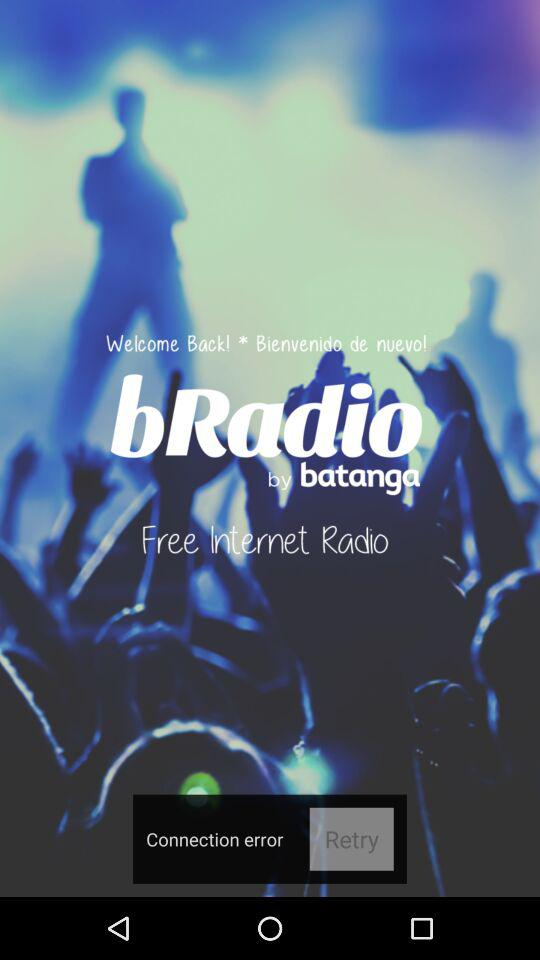What is the name of the application? The name of the application is "bRadio". 